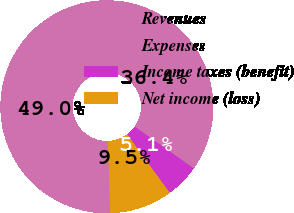<chart> <loc_0><loc_0><loc_500><loc_500><pie_chart><fcel>Revenues<fcel>Expenses<fcel>Income taxes (benefit)<fcel>Net income (loss)<nl><fcel>48.98%<fcel>36.37%<fcel>5.13%<fcel>9.52%<nl></chart> 